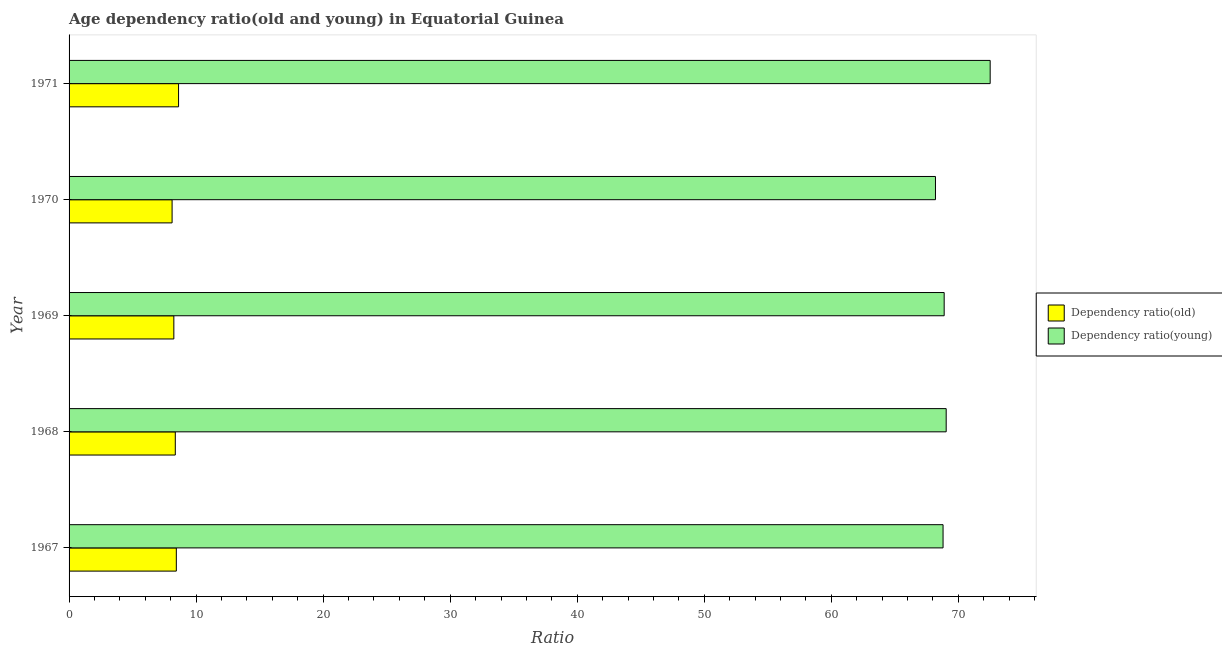Are the number of bars per tick equal to the number of legend labels?
Offer a terse response. Yes. Are the number of bars on each tick of the Y-axis equal?
Your answer should be compact. Yes. How many bars are there on the 3rd tick from the bottom?
Give a very brief answer. 2. What is the label of the 3rd group of bars from the top?
Your answer should be compact. 1969. In how many cases, is the number of bars for a given year not equal to the number of legend labels?
Your answer should be compact. 0. What is the age dependency ratio(young) in 1971?
Provide a short and direct response. 72.51. Across all years, what is the maximum age dependency ratio(old)?
Provide a short and direct response. 8.62. Across all years, what is the minimum age dependency ratio(young)?
Offer a very short reply. 68.2. In which year was the age dependency ratio(young) maximum?
Give a very brief answer. 1971. What is the total age dependency ratio(young) in the graph?
Offer a terse response. 347.44. What is the difference between the age dependency ratio(young) in 1968 and that in 1970?
Give a very brief answer. 0.84. What is the difference between the age dependency ratio(old) in 1971 and the age dependency ratio(young) in 1968?
Your response must be concise. -60.43. What is the average age dependency ratio(young) per year?
Offer a very short reply. 69.49. In the year 1969, what is the difference between the age dependency ratio(old) and age dependency ratio(young)?
Your answer should be very brief. -60.64. In how many years, is the age dependency ratio(old) greater than 18 ?
Ensure brevity in your answer.  0. What is the ratio of the age dependency ratio(young) in 1968 to that in 1970?
Ensure brevity in your answer.  1.01. Is the age dependency ratio(old) in 1969 less than that in 1971?
Provide a short and direct response. Yes. What is the difference between the highest and the second highest age dependency ratio(young)?
Provide a succinct answer. 3.46. What is the difference between the highest and the lowest age dependency ratio(young)?
Your answer should be very brief. 4.31. What does the 1st bar from the top in 1969 represents?
Provide a succinct answer. Dependency ratio(young). What does the 2nd bar from the bottom in 1968 represents?
Your response must be concise. Dependency ratio(young). How many bars are there?
Give a very brief answer. 10. Are all the bars in the graph horizontal?
Your answer should be compact. Yes. Does the graph contain grids?
Keep it short and to the point. No. Where does the legend appear in the graph?
Give a very brief answer. Center right. How are the legend labels stacked?
Make the answer very short. Vertical. What is the title of the graph?
Give a very brief answer. Age dependency ratio(old and young) in Equatorial Guinea. What is the label or title of the X-axis?
Your response must be concise. Ratio. What is the Ratio in Dependency ratio(old) in 1967?
Ensure brevity in your answer.  8.44. What is the Ratio in Dependency ratio(young) in 1967?
Ensure brevity in your answer.  68.8. What is the Ratio in Dependency ratio(old) in 1968?
Offer a very short reply. 8.36. What is the Ratio in Dependency ratio(young) in 1968?
Provide a short and direct response. 69.04. What is the Ratio in Dependency ratio(old) in 1969?
Give a very brief answer. 8.25. What is the Ratio in Dependency ratio(young) in 1969?
Give a very brief answer. 68.89. What is the Ratio of Dependency ratio(old) in 1970?
Your answer should be very brief. 8.11. What is the Ratio in Dependency ratio(young) in 1970?
Your answer should be compact. 68.2. What is the Ratio of Dependency ratio(old) in 1971?
Offer a terse response. 8.62. What is the Ratio of Dependency ratio(young) in 1971?
Keep it short and to the point. 72.51. Across all years, what is the maximum Ratio of Dependency ratio(old)?
Your response must be concise. 8.62. Across all years, what is the maximum Ratio in Dependency ratio(young)?
Offer a very short reply. 72.51. Across all years, what is the minimum Ratio of Dependency ratio(old)?
Provide a succinct answer. 8.11. Across all years, what is the minimum Ratio in Dependency ratio(young)?
Keep it short and to the point. 68.2. What is the total Ratio of Dependency ratio(old) in the graph?
Provide a short and direct response. 41.78. What is the total Ratio of Dependency ratio(young) in the graph?
Give a very brief answer. 347.44. What is the difference between the Ratio in Dependency ratio(old) in 1967 and that in 1968?
Your response must be concise. 0.08. What is the difference between the Ratio of Dependency ratio(young) in 1967 and that in 1968?
Ensure brevity in your answer.  -0.25. What is the difference between the Ratio in Dependency ratio(old) in 1967 and that in 1969?
Keep it short and to the point. 0.2. What is the difference between the Ratio of Dependency ratio(young) in 1967 and that in 1969?
Offer a very short reply. -0.09. What is the difference between the Ratio in Dependency ratio(old) in 1967 and that in 1970?
Offer a very short reply. 0.33. What is the difference between the Ratio of Dependency ratio(young) in 1967 and that in 1970?
Offer a terse response. 0.6. What is the difference between the Ratio in Dependency ratio(old) in 1967 and that in 1971?
Provide a short and direct response. -0.18. What is the difference between the Ratio of Dependency ratio(young) in 1967 and that in 1971?
Provide a succinct answer. -3.71. What is the difference between the Ratio of Dependency ratio(old) in 1968 and that in 1969?
Offer a terse response. 0.11. What is the difference between the Ratio of Dependency ratio(young) in 1968 and that in 1969?
Provide a short and direct response. 0.16. What is the difference between the Ratio in Dependency ratio(old) in 1968 and that in 1970?
Offer a terse response. 0.25. What is the difference between the Ratio in Dependency ratio(young) in 1968 and that in 1970?
Offer a very short reply. 0.84. What is the difference between the Ratio of Dependency ratio(old) in 1968 and that in 1971?
Your answer should be very brief. -0.26. What is the difference between the Ratio of Dependency ratio(young) in 1968 and that in 1971?
Make the answer very short. -3.46. What is the difference between the Ratio of Dependency ratio(old) in 1969 and that in 1970?
Make the answer very short. 0.14. What is the difference between the Ratio in Dependency ratio(young) in 1969 and that in 1970?
Keep it short and to the point. 0.69. What is the difference between the Ratio in Dependency ratio(old) in 1969 and that in 1971?
Your answer should be very brief. -0.37. What is the difference between the Ratio in Dependency ratio(young) in 1969 and that in 1971?
Make the answer very short. -3.62. What is the difference between the Ratio in Dependency ratio(old) in 1970 and that in 1971?
Your answer should be compact. -0.51. What is the difference between the Ratio in Dependency ratio(young) in 1970 and that in 1971?
Your response must be concise. -4.31. What is the difference between the Ratio in Dependency ratio(old) in 1967 and the Ratio in Dependency ratio(young) in 1968?
Your answer should be very brief. -60.6. What is the difference between the Ratio in Dependency ratio(old) in 1967 and the Ratio in Dependency ratio(young) in 1969?
Make the answer very short. -60.44. What is the difference between the Ratio in Dependency ratio(old) in 1967 and the Ratio in Dependency ratio(young) in 1970?
Provide a succinct answer. -59.76. What is the difference between the Ratio of Dependency ratio(old) in 1967 and the Ratio of Dependency ratio(young) in 1971?
Give a very brief answer. -64.06. What is the difference between the Ratio of Dependency ratio(old) in 1968 and the Ratio of Dependency ratio(young) in 1969?
Offer a very short reply. -60.53. What is the difference between the Ratio of Dependency ratio(old) in 1968 and the Ratio of Dependency ratio(young) in 1970?
Make the answer very short. -59.84. What is the difference between the Ratio in Dependency ratio(old) in 1968 and the Ratio in Dependency ratio(young) in 1971?
Keep it short and to the point. -64.15. What is the difference between the Ratio of Dependency ratio(old) in 1969 and the Ratio of Dependency ratio(young) in 1970?
Your response must be concise. -59.95. What is the difference between the Ratio of Dependency ratio(old) in 1969 and the Ratio of Dependency ratio(young) in 1971?
Offer a very short reply. -64.26. What is the difference between the Ratio of Dependency ratio(old) in 1970 and the Ratio of Dependency ratio(young) in 1971?
Ensure brevity in your answer.  -64.4. What is the average Ratio of Dependency ratio(old) per year?
Keep it short and to the point. 8.36. What is the average Ratio in Dependency ratio(young) per year?
Give a very brief answer. 69.49. In the year 1967, what is the difference between the Ratio of Dependency ratio(old) and Ratio of Dependency ratio(young)?
Your answer should be compact. -60.35. In the year 1968, what is the difference between the Ratio in Dependency ratio(old) and Ratio in Dependency ratio(young)?
Provide a short and direct response. -60.68. In the year 1969, what is the difference between the Ratio of Dependency ratio(old) and Ratio of Dependency ratio(young)?
Your answer should be compact. -60.64. In the year 1970, what is the difference between the Ratio of Dependency ratio(old) and Ratio of Dependency ratio(young)?
Your answer should be compact. -60.09. In the year 1971, what is the difference between the Ratio in Dependency ratio(old) and Ratio in Dependency ratio(young)?
Provide a short and direct response. -63.89. What is the ratio of the Ratio in Dependency ratio(old) in 1967 to that in 1968?
Offer a terse response. 1.01. What is the ratio of the Ratio in Dependency ratio(old) in 1967 to that in 1969?
Your answer should be compact. 1.02. What is the ratio of the Ratio in Dependency ratio(young) in 1967 to that in 1969?
Ensure brevity in your answer.  1. What is the ratio of the Ratio in Dependency ratio(old) in 1967 to that in 1970?
Offer a very short reply. 1.04. What is the ratio of the Ratio of Dependency ratio(young) in 1967 to that in 1970?
Ensure brevity in your answer.  1.01. What is the ratio of the Ratio of Dependency ratio(old) in 1967 to that in 1971?
Offer a terse response. 0.98. What is the ratio of the Ratio in Dependency ratio(young) in 1967 to that in 1971?
Keep it short and to the point. 0.95. What is the ratio of the Ratio of Dependency ratio(old) in 1968 to that in 1969?
Provide a succinct answer. 1.01. What is the ratio of the Ratio of Dependency ratio(old) in 1968 to that in 1970?
Your response must be concise. 1.03. What is the ratio of the Ratio in Dependency ratio(young) in 1968 to that in 1970?
Keep it short and to the point. 1.01. What is the ratio of the Ratio in Dependency ratio(old) in 1968 to that in 1971?
Keep it short and to the point. 0.97. What is the ratio of the Ratio of Dependency ratio(young) in 1968 to that in 1971?
Offer a very short reply. 0.95. What is the ratio of the Ratio in Dependency ratio(old) in 1969 to that in 1970?
Provide a short and direct response. 1.02. What is the ratio of the Ratio in Dependency ratio(old) in 1969 to that in 1971?
Make the answer very short. 0.96. What is the ratio of the Ratio in Dependency ratio(young) in 1969 to that in 1971?
Ensure brevity in your answer.  0.95. What is the ratio of the Ratio in Dependency ratio(old) in 1970 to that in 1971?
Offer a very short reply. 0.94. What is the ratio of the Ratio of Dependency ratio(young) in 1970 to that in 1971?
Offer a very short reply. 0.94. What is the difference between the highest and the second highest Ratio in Dependency ratio(old)?
Give a very brief answer. 0.18. What is the difference between the highest and the second highest Ratio in Dependency ratio(young)?
Provide a succinct answer. 3.46. What is the difference between the highest and the lowest Ratio in Dependency ratio(old)?
Provide a short and direct response. 0.51. What is the difference between the highest and the lowest Ratio of Dependency ratio(young)?
Keep it short and to the point. 4.31. 